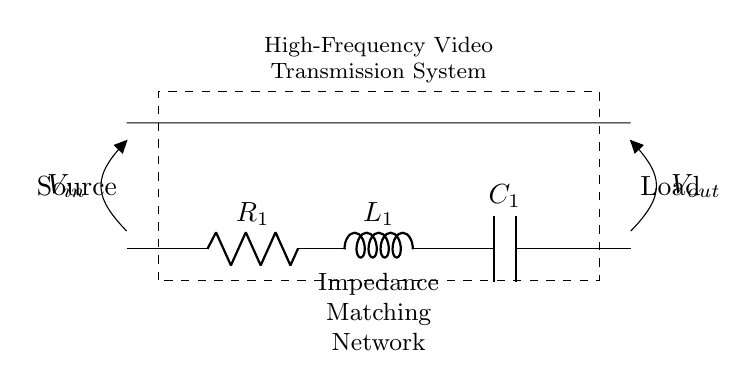What is the value of the resistor in the circuit? The circuit shows a resistor labeled as R_1. To determine the value, we refer to the label. In this case, it is a variable letter representing a component rather than a specific numerical value.
Answer: R_1 What component follows the resistor in the circuit diagram? The circuit shows the components arranged in series. After R_1, the next component is labeled as L_1, which represents an inductor.
Answer: L_1 How many components are there in the impedance matching network? The impedance matching network consists of three components depicted in the diagram: R_1 (resistor), L_1 (inductor), and C_1 (capacitor). Counting these gives a total of three components.
Answer: Three What is the purpose of the capacitor in this network? The capacitor, labeled as C_1, serves as a reactive component in the circuit, which is essential for frequency-dependent impedance matching. It helps to balance or tune the overall impedance seen by the source and load for optimal power transfer.
Answer: Impedance matching What is the relationship between the components in this circuit? The components in the circuit are organized in series, meaning that the current flows through R_1, then L_1, followed by C_1 in a single path. This arrangement affects the total impedance of the network, which is critical at high frequencies.
Answer: Series arrangement What type of circuit is this impedance matching network? The circuit consists of a combination of resistive, inductive, and capacitive components. Therefore, it is categorized as a second-order RLC circuit, where impedance is influenced by the presence of both L and C.
Answer: RLC circuit 